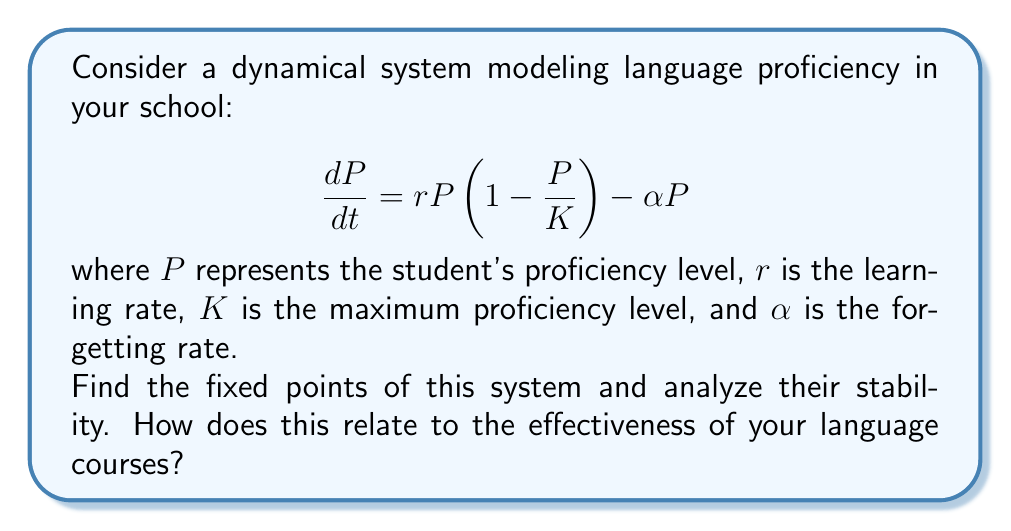Can you answer this question? 1. To find the fixed points, set $\frac{dP}{dt} = 0$:

   $$rP(1-\frac{P}{K}) - \alpha P = 0$$

2. Factor out $P$:

   $$P(r(1-\frac{P}{K}) - \alpha) = 0$$

3. Solve for $P$:
   - $P = 0$ is one fixed point
   - For the other, solve $r(1-\frac{P}{K}) - \alpha = 0$
     $$r - \frac{rP}{K} - \alpha = 0$$
     $$r - \alpha = \frac{rP}{K}$$
     $$P = K(1-\frac{\alpha}{r})$$

4. The fixed points are $P_1 = 0$ and $P_2 = K(1-\frac{\alpha}{r})$

5. To analyze stability, find $\frac{d}{dP}(\frac{dP}{dt})$ at each fixed point:

   $$\frac{d}{dP}(\frac{dP}{dt}) = r(1-\frac{2P}{K}) - \alpha$$

6. At $P_1 = 0$:
   $$\frac{d}{dP}(\frac{dP}{dt})|_{P=0} = r - \alpha$$
   - If $r > \alpha$, $P_1$ is unstable
   - If $r < \alpha$, $P_1$ is stable

7. At $P_2 = K(1-\frac{\alpha}{r})$:
   $$\frac{d}{dP}(\frac{dP}{dt})|_{P=P_2} = r(1-\frac{2K(1-\frac{\alpha}{r})}{K}) - \alpha = \alpha - r$$
   - If $r > \alpha$, $P_2$ is stable
   - If $r < \alpha$, $P_2$ is unstable (and negative, thus irrelevant)

8. For effective language courses:
   - Ensure $r > \alpha$ (learning rate exceeds forgetting rate)
   - $P_2 = K(1-\frac{\alpha}{r})$ represents the stable proficiency level students will approach
   - Higher $r$ and lower $\alpha$ lead to higher stable proficiency levels
Answer: Fixed points: $P_1 = 0$, $P_2 = K(1-\frac{\alpha}{r})$. For effective courses, ensure $r > \alpha$, making $P_1$ unstable and $P_2$ stable and positive. 